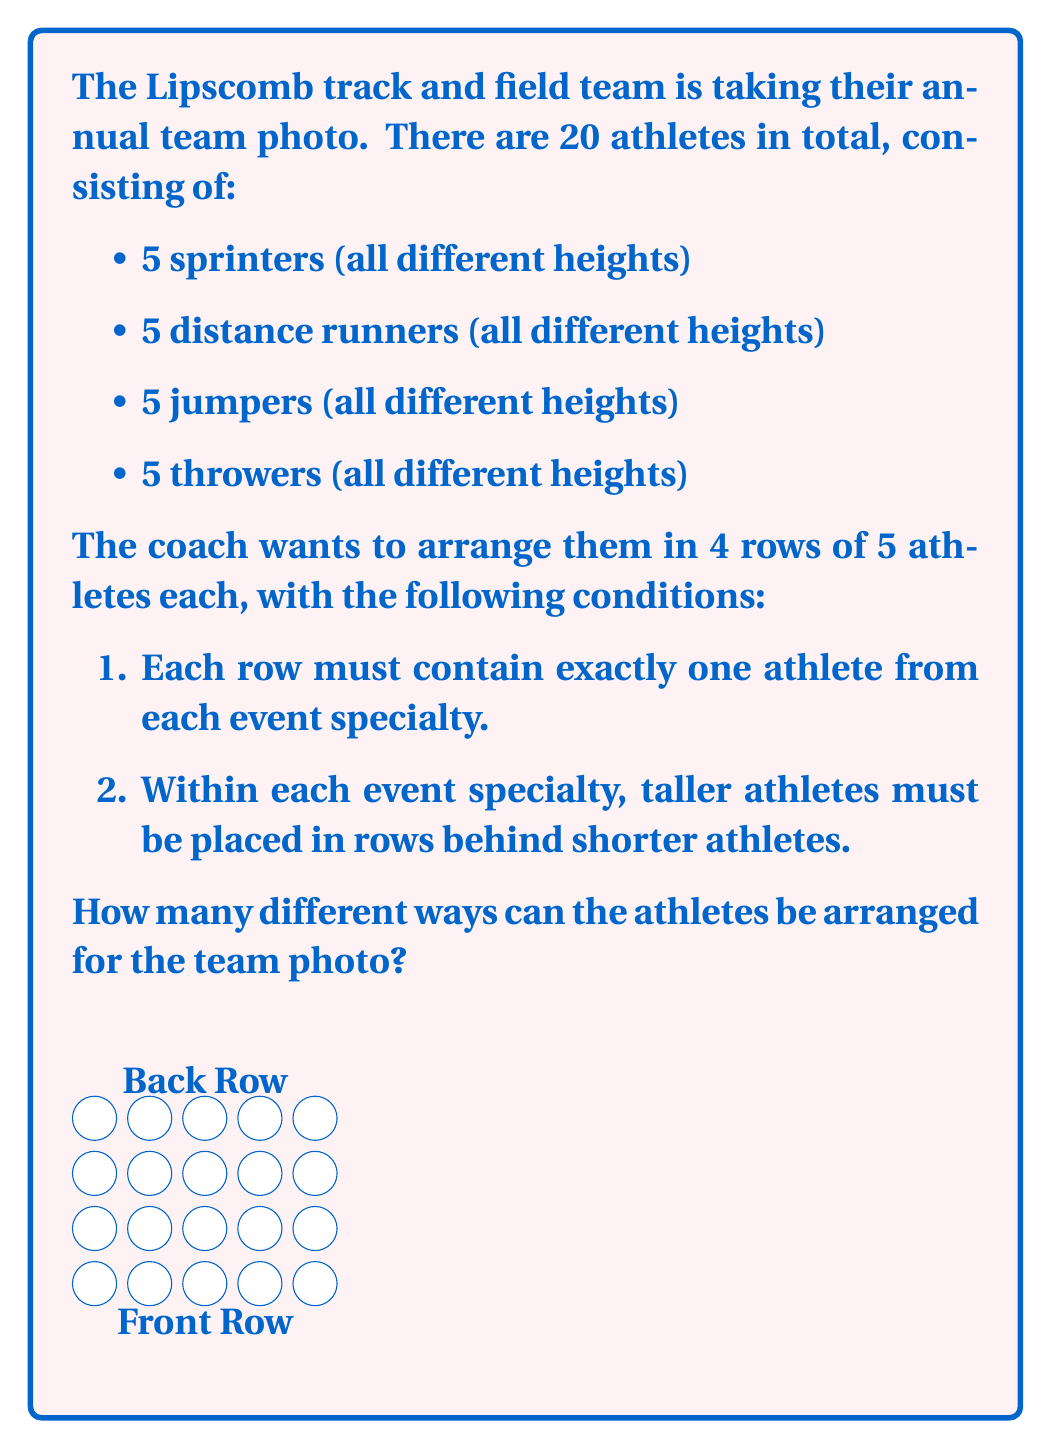Help me with this question. Let's approach this step-by-step:

1) First, we need to choose which athlete from each specialty goes in each row. This is equivalent to arranging 5 athletes of each specialty in a column.

2) For each specialty, we have 5! ways to arrange the athletes vertically (remembering that taller athletes must be behind shorter ones).

3) We have 4 specialties, so we multiply these arrangements:

   $$(5!)^4$$

4) Now, within each row, we can arrange the 4 athletes (one from each specialty) in any order.

5) We have 4 rows, and each row can be arranged in 4! ways.

6) So we multiply our previous result by $(4!)^4$:

   $$(5!)^4 \cdot (4!)^4$$

7) Let's calculate this:
   
   $$(5!)^4 = (120)^4 = 207,360,000$$
   $(4!)^4 = (24)^4 = 331,776$$

   $207,360,000 \cdot 331,776 = 68,799,283,200,000$

Therefore, there are 68,799,283,200,000 different ways to arrange the athletes for the team photo.
Answer: $$68,799,283,200,000$$ 